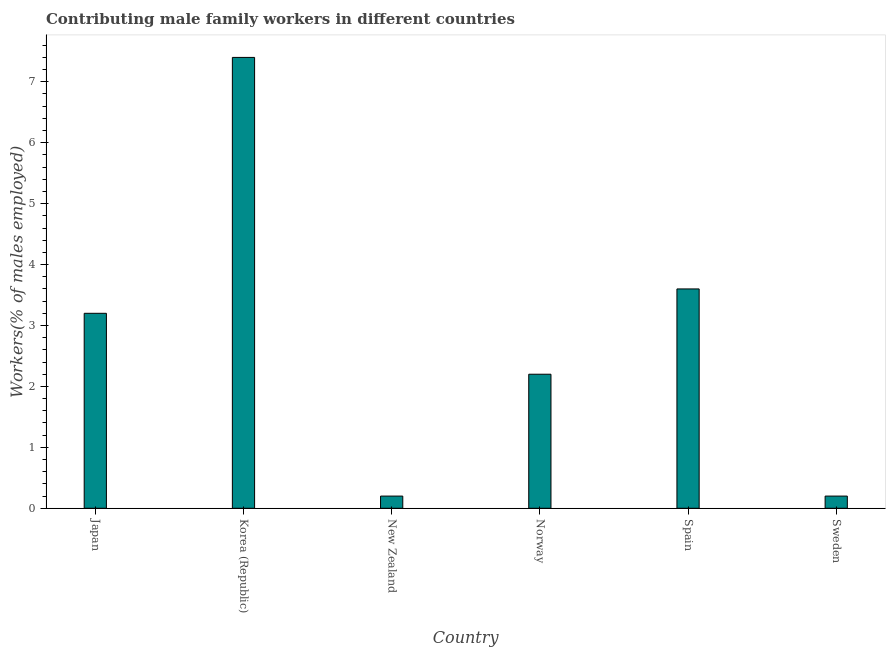Does the graph contain grids?
Ensure brevity in your answer.  No. What is the title of the graph?
Provide a succinct answer. Contributing male family workers in different countries. What is the label or title of the Y-axis?
Provide a short and direct response. Workers(% of males employed). What is the contributing male family workers in Japan?
Your answer should be compact. 3.2. Across all countries, what is the maximum contributing male family workers?
Your answer should be very brief. 7.4. Across all countries, what is the minimum contributing male family workers?
Give a very brief answer. 0.2. In which country was the contributing male family workers minimum?
Give a very brief answer. New Zealand. What is the sum of the contributing male family workers?
Your answer should be very brief. 16.8. What is the median contributing male family workers?
Your answer should be very brief. 2.7. What is the ratio of the contributing male family workers in Japan to that in Spain?
Keep it short and to the point. 0.89. Is the difference between the contributing male family workers in Spain and Sweden greater than the difference between any two countries?
Offer a terse response. No. How many bars are there?
Offer a terse response. 6. Are all the bars in the graph horizontal?
Offer a very short reply. No. How many countries are there in the graph?
Ensure brevity in your answer.  6. Are the values on the major ticks of Y-axis written in scientific E-notation?
Your response must be concise. No. What is the Workers(% of males employed) in Japan?
Your answer should be compact. 3.2. What is the Workers(% of males employed) in Korea (Republic)?
Provide a succinct answer. 7.4. What is the Workers(% of males employed) in New Zealand?
Offer a very short reply. 0.2. What is the Workers(% of males employed) of Norway?
Provide a succinct answer. 2.2. What is the Workers(% of males employed) of Spain?
Provide a succinct answer. 3.6. What is the Workers(% of males employed) of Sweden?
Your answer should be compact. 0.2. What is the difference between the Workers(% of males employed) in Japan and Korea (Republic)?
Your response must be concise. -4.2. What is the difference between the Workers(% of males employed) in Japan and New Zealand?
Ensure brevity in your answer.  3. What is the difference between the Workers(% of males employed) in Japan and Norway?
Give a very brief answer. 1. What is the difference between the Workers(% of males employed) in Japan and Spain?
Offer a terse response. -0.4. What is the difference between the Workers(% of males employed) in Japan and Sweden?
Provide a short and direct response. 3. What is the difference between the Workers(% of males employed) in Norway and Spain?
Make the answer very short. -1.4. What is the difference between the Workers(% of males employed) in Spain and Sweden?
Your answer should be compact. 3.4. What is the ratio of the Workers(% of males employed) in Japan to that in Korea (Republic)?
Your answer should be very brief. 0.43. What is the ratio of the Workers(% of males employed) in Japan to that in New Zealand?
Ensure brevity in your answer.  16. What is the ratio of the Workers(% of males employed) in Japan to that in Norway?
Your answer should be very brief. 1.46. What is the ratio of the Workers(% of males employed) in Japan to that in Spain?
Provide a succinct answer. 0.89. What is the ratio of the Workers(% of males employed) in Japan to that in Sweden?
Keep it short and to the point. 16. What is the ratio of the Workers(% of males employed) in Korea (Republic) to that in Norway?
Keep it short and to the point. 3.36. What is the ratio of the Workers(% of males employed) in Korea (Republic) to that in Spain?
Provide a short and direct response. 2.06. What is the ratio of the Workers(% of males employed) in Korea (Republic) to that in Sweden?
Offer a terse response. 37. What is the ratio of the Workers(% of males employed) in New Zealand to that in Norway?
Provide a succinct answer. 0.09. What is the ratio of the Workers(% of males employed) in New Zealand to that in Spain?
Provide a succinct answer. 0.06. What is the ratio of the Workers(% of males employed) in New Zealand to that in Sweden?
Provide a short and direct response. 1. What is the ratio of the Workers(% of males employed) in Norway to that in Spain?
Provide a short and direct response. 0.61. What is the ratio of the Workers(% of males employed) in Norway to that in Sweden?
Provide a short and direct response. 11. 